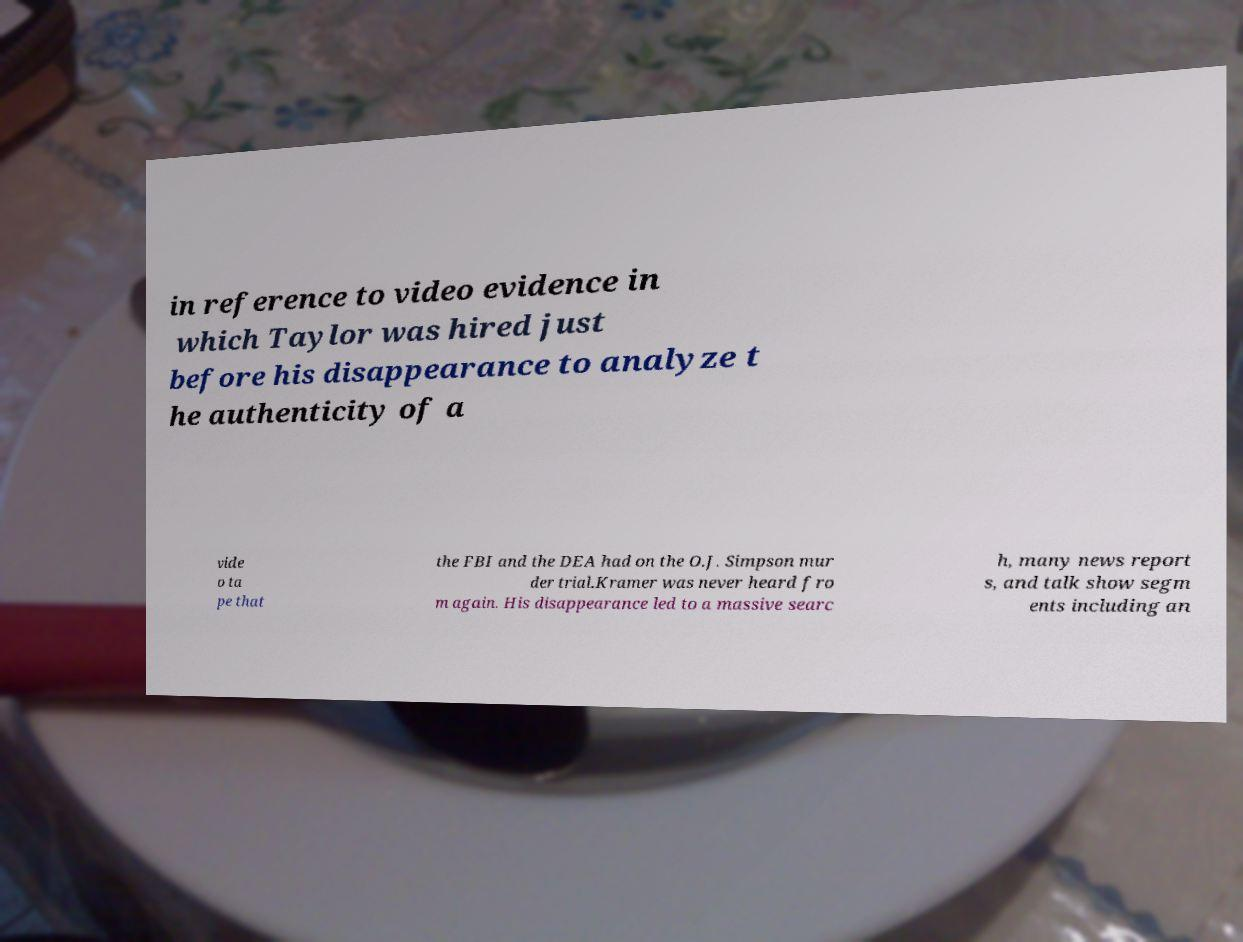There's text embedded in this image that I need extracted. Can you transcribe it verbatim? in reference to video evidence in which Taylor was hired just before his disappearance to analyze t he authenticity of a vide o ta pe that the FBI and the DEA had on the O.J. Simpson mur der trial.Kramer was never heard fro m again. His disappearance led to a massive searc h, many news report s, and talk show segm ents including an 